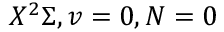Convert formula to latex. <formula><loc_0><loc_0><loc_500><loc_500>X ^ { 2 } \Sigma , v = 0 , N = 0</formula> 